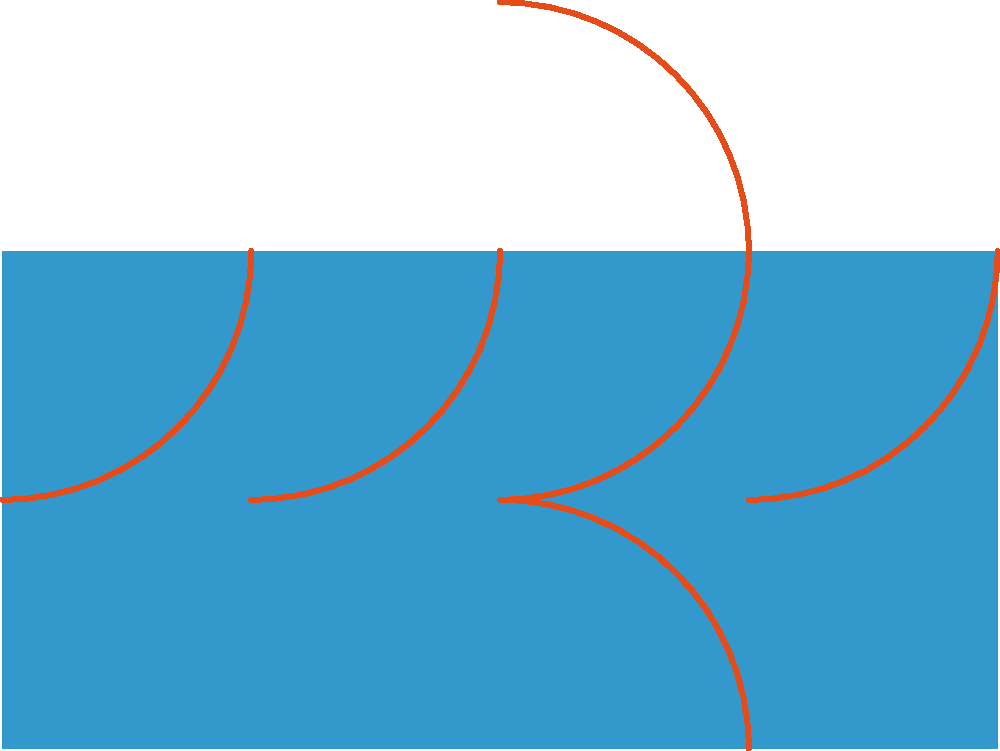A food truck owner wants to create a flowing, continuous design for their vinyl wrap. The design starts with a quarter-circle arc that spans 2.5 units horizontally and vertically. To cover the entire truck, which is 10 units long and 5 units tall, the owner applies the following transformations:

1. Translate the original arc horizontally 3 times, each by 2.5 units.
2. Rotate the original arc 90° clockwise and translate it to the left side of the truck.
3. Translate the rotated arc vertically by 5 units.

How many total arcs are needed to complete this design? Let's break this down step by step:

1. Original horizontal arcs:
   - We start with one arc
   - We translate it 3 times, each creating a new arc
   - This gives us 1 + 3 = 4 horizontal arcs

2. Rotated arc on the left side:
   - We rotate the original arc 90° clockwise
   - We place this on the left side of the truck
   - This adds 1 more arc

3. Translated rotated arc:
   - We take the rotated arc from step 2
   - We translate it vertically by 5 units
   - This adds 1 more arc

4. Total count:
   - Horizontal arcs: 4
   - Left side arcs: 2
   - Total: 4 + 2 = 6 arcs

Therefore, the design requires a total of 6 arcs to complete the flowing, continuous pattern across the entire food truck wrap.
Answer: 6 arcs 